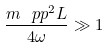<formula> <loc_0><loc_0><loc_500><loc_500>\frac { m _ { \ } p p ^ { 2 } L } { 4 \omega } \gg 1</formula> 